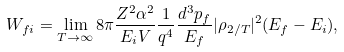<formula> <loc_0><loc_0><loc_500><loc_500>W _ { f i } = \lim _ { T \rightarrow \infty } 8 \pi \frac { Z ^ { 2 } \alpha ^ { 2 } } { E _ { i } V } \frac { 1 } { q ^ { 4 } } \frac { d ^ { 3 } p _ { f } } { E _ { f } } | \rho _ { 2 / T } | ^ { 2 } ( E _ { f } - E _ { i } ) ,</formula> 